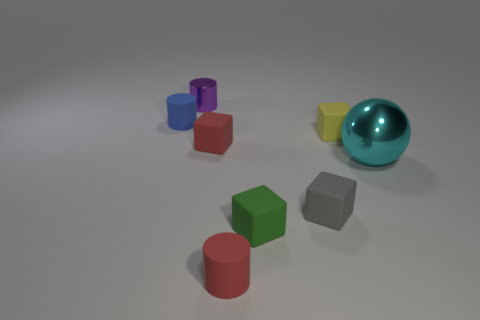Subtract 1 cubes. How many cubes are left? 3 Add 1 purple things. How many objects exist? 9 Subtract all cylinders. How many objects are left? 5 Subtract all metallic balls. Subtract all tiny rubber cylinders. How many objects are left? 5 Add 1 green rubber objects. How many green rubber objects are left? 2 Add 6 yellow matte things. How many yellow matte things exist? 7 Subtract 0 brown cubes. How many objects are left? 8 